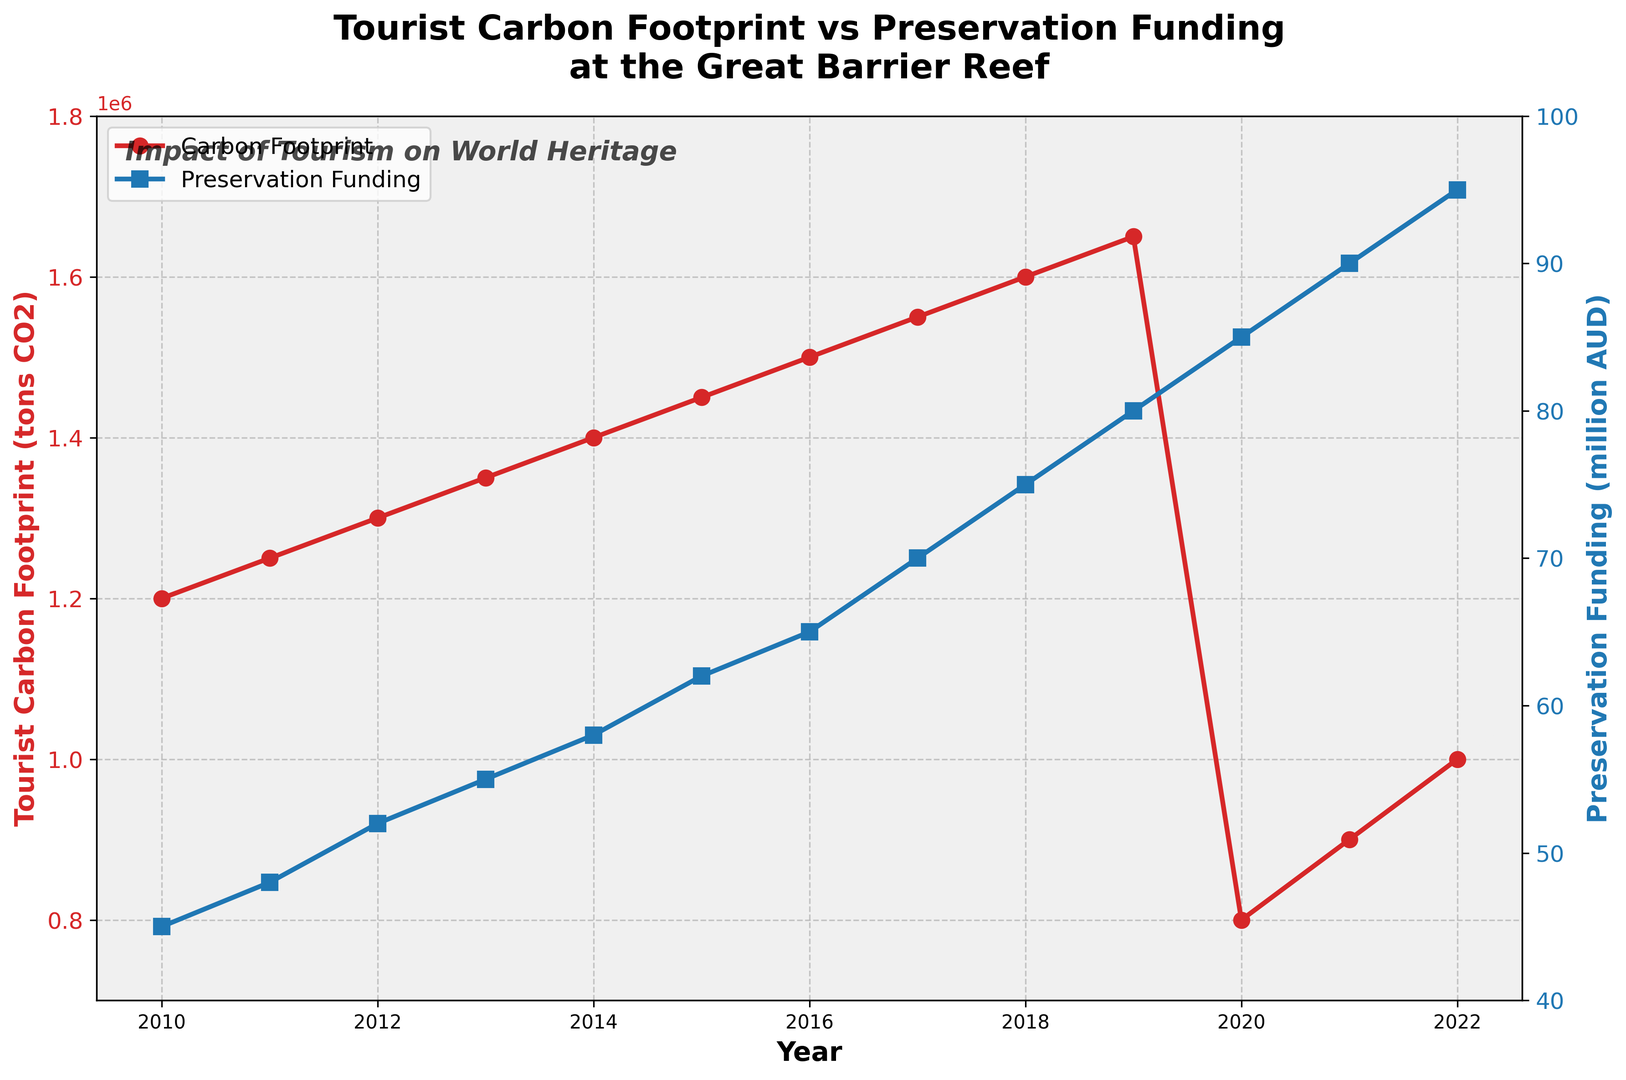What's the trend in the Tourist Carbon Footprint from 2010 to 2019? From the figure, the Tourist Carbon Footprint increases steadily every year from 2010 (1,200,000 tons CO2) to 2019 (1,650,000 tons CO2).
Answer: Steadily increasing How does the Tourist Carbon Footprint in 2020 compare to the previous year? The Tourist Carbon Footprint in 2020 is significantly lower than in 2019. In 2019, it was 1,650,000 tons CO2, whereas, in 2020, it dropped to 800,000 tons CO2.
Answer: Much lower What is the overall trend in Preservation Funding from 2010 to 2022? Preservation Funding shows a consistent upward trend from 2010 (45 million AUD) to 2022 (95 million AUD).
Answer: Consistent increase In which year did the Preservation Funding reach 70 million AUD? By looking at the blue curve, Preservation Funding reached 70 million AUD in 2017.
Answer: 2017 Which year experienced the highest Tourist Carbon Footprint? The highest Tourist Carbon Footprint is observed in 2019, which is 1,650,000 tons CO2.
Answer: 2019 Compare the change in Preservation Funding and Tourist Carbon Footprint from 2019 to 2020. From 2019 to 2020, the Preservation Funding increased from 80 million AUD to 85 million AUD, while the Tourist Carbon Footprint dropped significantly from 1,650,000 tons CO2 to 800,000 tons CO2.
Answer: Preservation Funding increased, Carbon Footprint decreased What visual differences can you observe between the two data series in the plot? The Carbon Footprint data is represented by a red line with circular markers, while the Preservation Funding data is represented by a blue line with square markers. Additionally, the preservation funding scale is on a secondary y-axis on the right.
Answer: Different colors, markers, and y-axes What is the average Preservation Funding between 2010 and 2022? To find the average, sum up the Preservation Funding values from 2010 to 2022 then divide by 13. (45 + 48 + 52 + 55 + 58 + 62 + 65 + 70 + 75 + 80 + 85 + 90 + 95) / 13 = 880 / 13 ≈ 67.69 million AUD
Answer: 67.69 million AUD How did the COVID-19 pandemic affect the Tourist Carbon Footprint? The Tourist Carbon Footprint sharply decreased in 2020 to 800,000 tons CO2, likely due to reduced tourism during the pandemic.
Answer: Sharp decrease Were there any years where both Preservation Funding and Tourist Carbon Footprint both increased simultaneously? Yes, from 2010 to 2019, both Preservation Funding and Tourist Carbon Footprint increased every year.
Answer: 2010 to 2019 